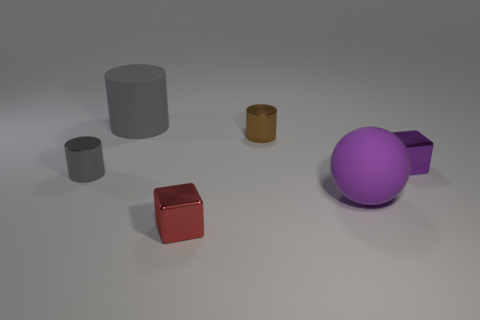What number of shiny things are to the right of the tiny metallic cylinder on the right side of the small object that is left of the large gray matte object?
Your answer should be compact. 1. What is the shape of the large gray object that is made of the same material as the purple sphere?
Your response must be concise. Cylinder. What material is the purple block to the right of the purple thing that is in front of the small thing left of the big gray thing?
Make the answer very short. Metal. How many things are metal cubes that are behind the purple matte thing or large gray things?
Make the answer very short. 2. What number of other objects are the same shape as the small red thing?
Your response must be concise. 1. Is the number of metal cubes on the right side of the tiny purple metal object greater than the number of gray shiny things?
Keep it short and to the point. No. What is the size of the other rubber thing that is the same shape as the small brown thing?
Offer a very short reply. Large. The small red object has what shape?
Offer a terse response. Cube. What shape is the gray thing that is the same size as the red shiny object?
Make the answer very short. Cylinder. Is there anything else that is the same color as the ball?
Give a very brief answer. Yes. 